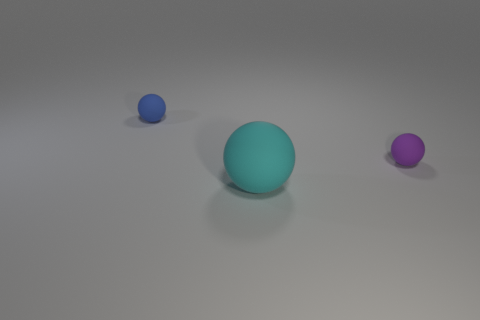Add 1 big cyan spheres. How many objects exist? 4 Subtract all large brown metallic balls. Subtract all cyan matte objects. How many objects are left? 2 Add 2 purple matte spheres. How many purple matte spheres are left? 3 Add 1 large cyan rubber balls. How many large cyan rubber balls exist? 2 Subtract 0 green cylinders. How many objects are left? 3 